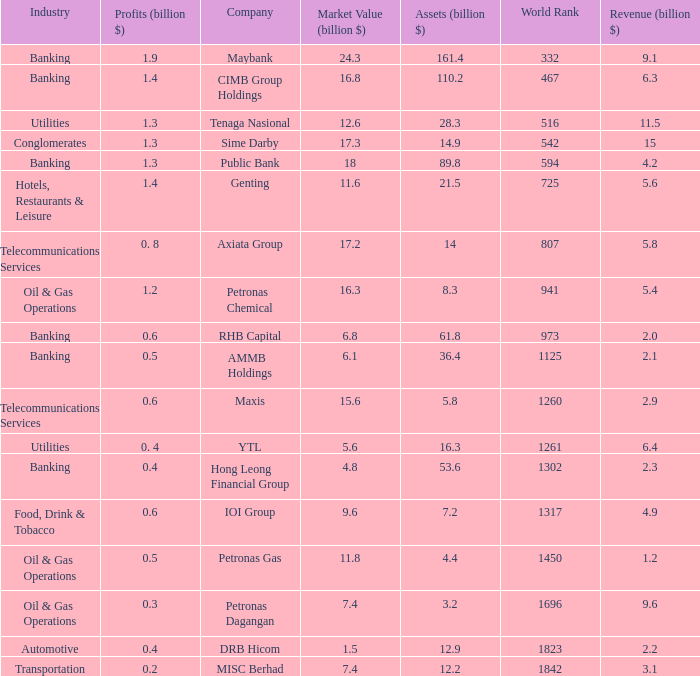Name the profits for market value of 11.8 0.5. 